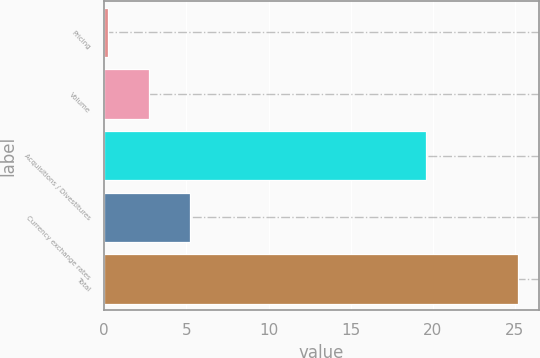Convert chart to OTSL. <chart><loc_0><loc_0><loc_500><loc_500><bar_chart><fcel>Pricing<fcel>Volume<fcel>Acquisitions / Divestitures<fcel>Currency exchange rates<fcel>Total<nl><fcel>0.2<fcel>2.7<fcel>19.6<fcel>5.2<fcel>25.2<nl></chart> 